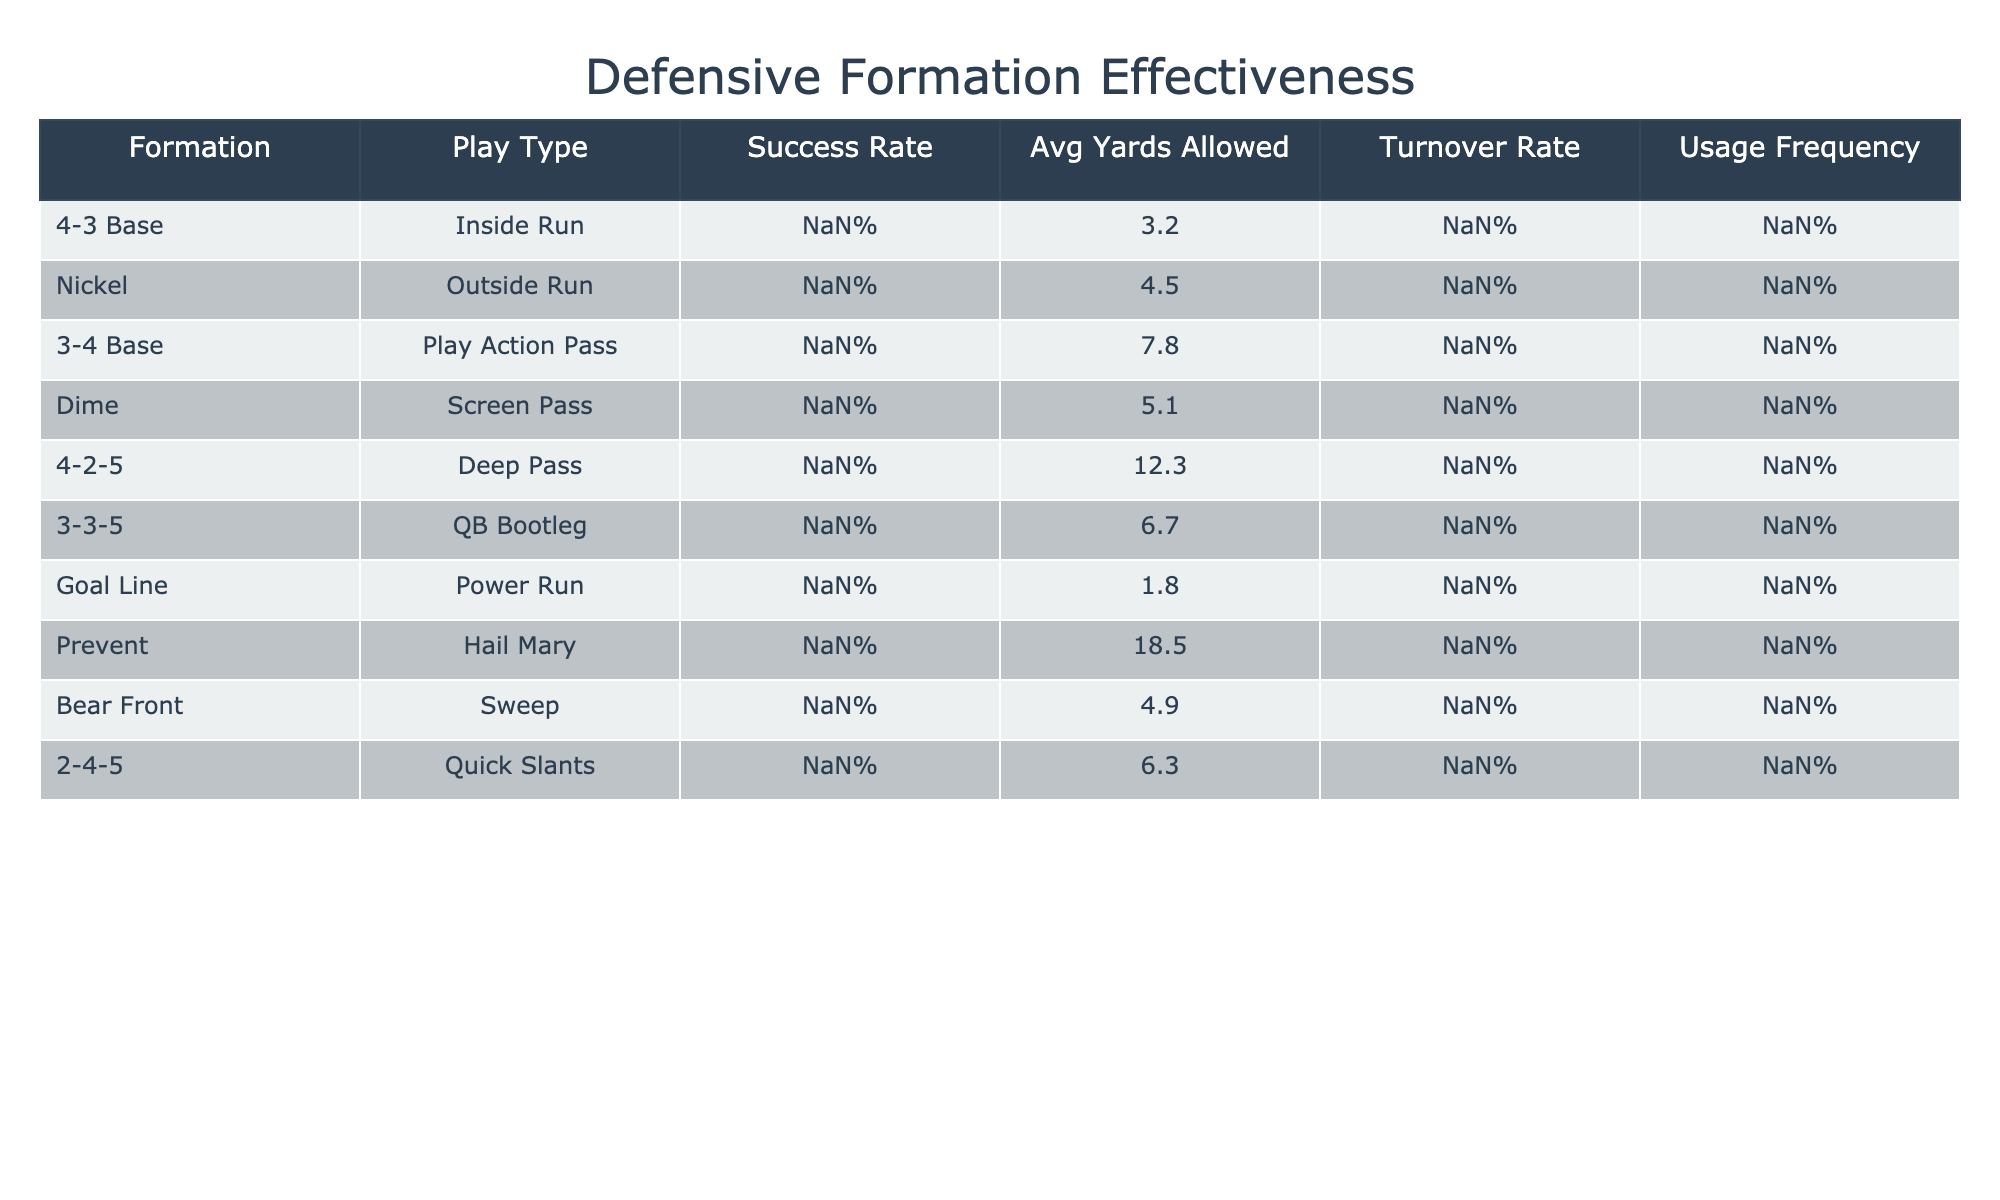What is the success rate of the Goal Line formation against the Power Run? According to the table, the Goal Line formation has a success rate of 72% against the Power Run.
Answer: 72% Which formation allowed the most average yards against its respective play type? The formation that allowed the most average yards is the 4-2-5 against the Deep Pass, allowing 12.3 yards.
Answer: 12.3 yards What is the turnover rate for the Dime formation during the Screen Pass? The table lists a turnover rate of 1% for the Dime formation when facing the Screen Pass.
Answer: 1% How many formations have a success rate below 50%? In the table, only the 4-2-5 formation against the Deep Pass has a success rate below 50%, which is 45%.
Answer: 1 Which play type had the highest usage frequency? Looking at the table, the Inside Run has the highest usage frequency at 22%.
Answer: 22% What is the average success rate of the 4-3 Base and 3-4 Base formations? The 4-3 Base has a success rate of 68% and the 3-4 Base has 55%. Thus, the average success rate is (68 + 55) / 2 = 61.5%.
Answer: 61.5% Is the Prevent formation effective against Hail Mary plays? The Prevent formation has a success rate of 25% against Hail Mary plays, indicating it is not effective.
Answer: No How does the success rate of the Nickel formation compare to that of the Bear Front? The Nickel formation has a success rate of 62%, while the Bear Front has 64%. This shows that the Bear Front is slightly more successful.
Answer: Bear Front is slightly better If you sum the usage frequencies of all formations, what is the total? Adding all the usage frequencies (22 + 18 + 15 + 12 + 10 + 8 + 6 + 3 + 4 + 7) gives a total of 125%.
Answer: 125% Which play type had the lowest turnover rate? The play type with the lowest turnover rate is the Nickel formation against the Outside Run, with a turnover rate of 1%.
Answer: 1% 